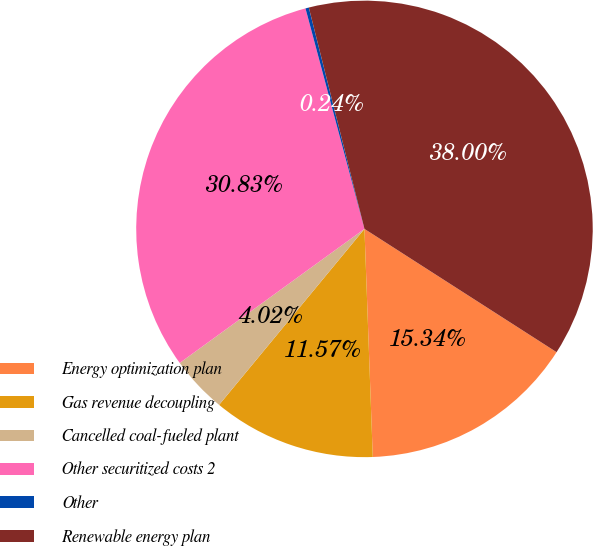<chart> <loc_0><loc_0><loc_500><loc_500><pie_chart><fcel>Energy optimization plan<fcel>Gas revenue decoupling<fcel>Cancelled coal-fueled plant<fcel>Other securitized costs 2<fcel>Other<fcel>Renewable energy plan<nl><fcel>15.34%<fcel>11.57%<fcel>4.02%<fcel>30.83%<fcel>0.24%<fcel>38.0%<nl></chart> 